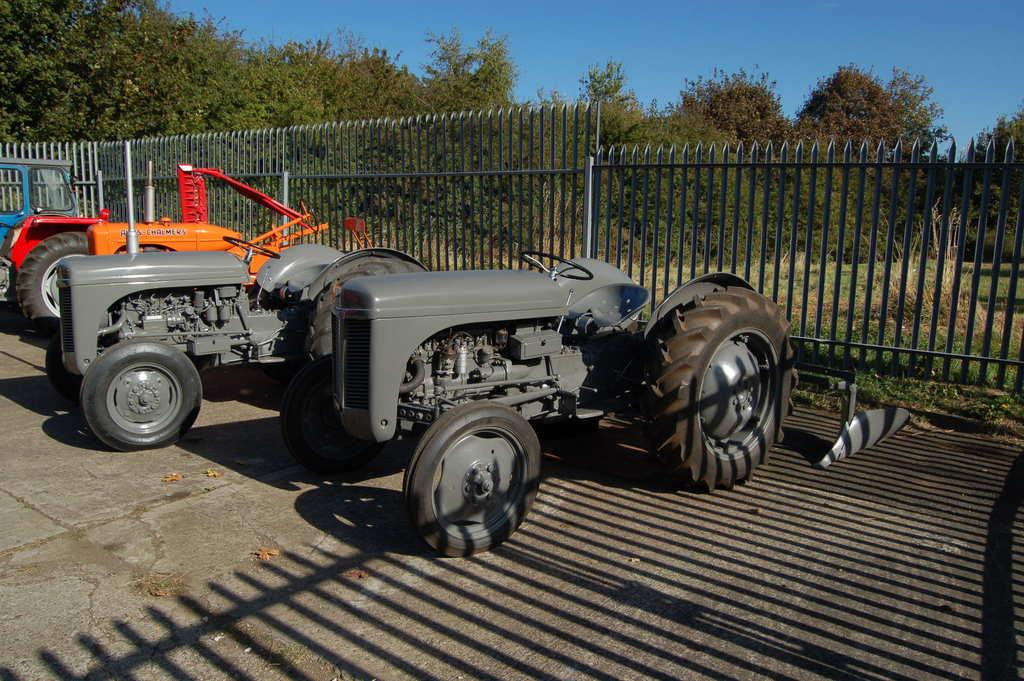What type of vehicles are in the foreground of the image? There are tractors in the foreground of the image. What separates the different areas in the image? There is a boundary in the image. What type of vegetation can be seen in the background of the image? There are trees in the background of the image. What is visible above the boundary and trees in the image? The sky is visible in the image. What decision was made at the camp in the image? There is no camp present in the image, so no decision can be made about it. 